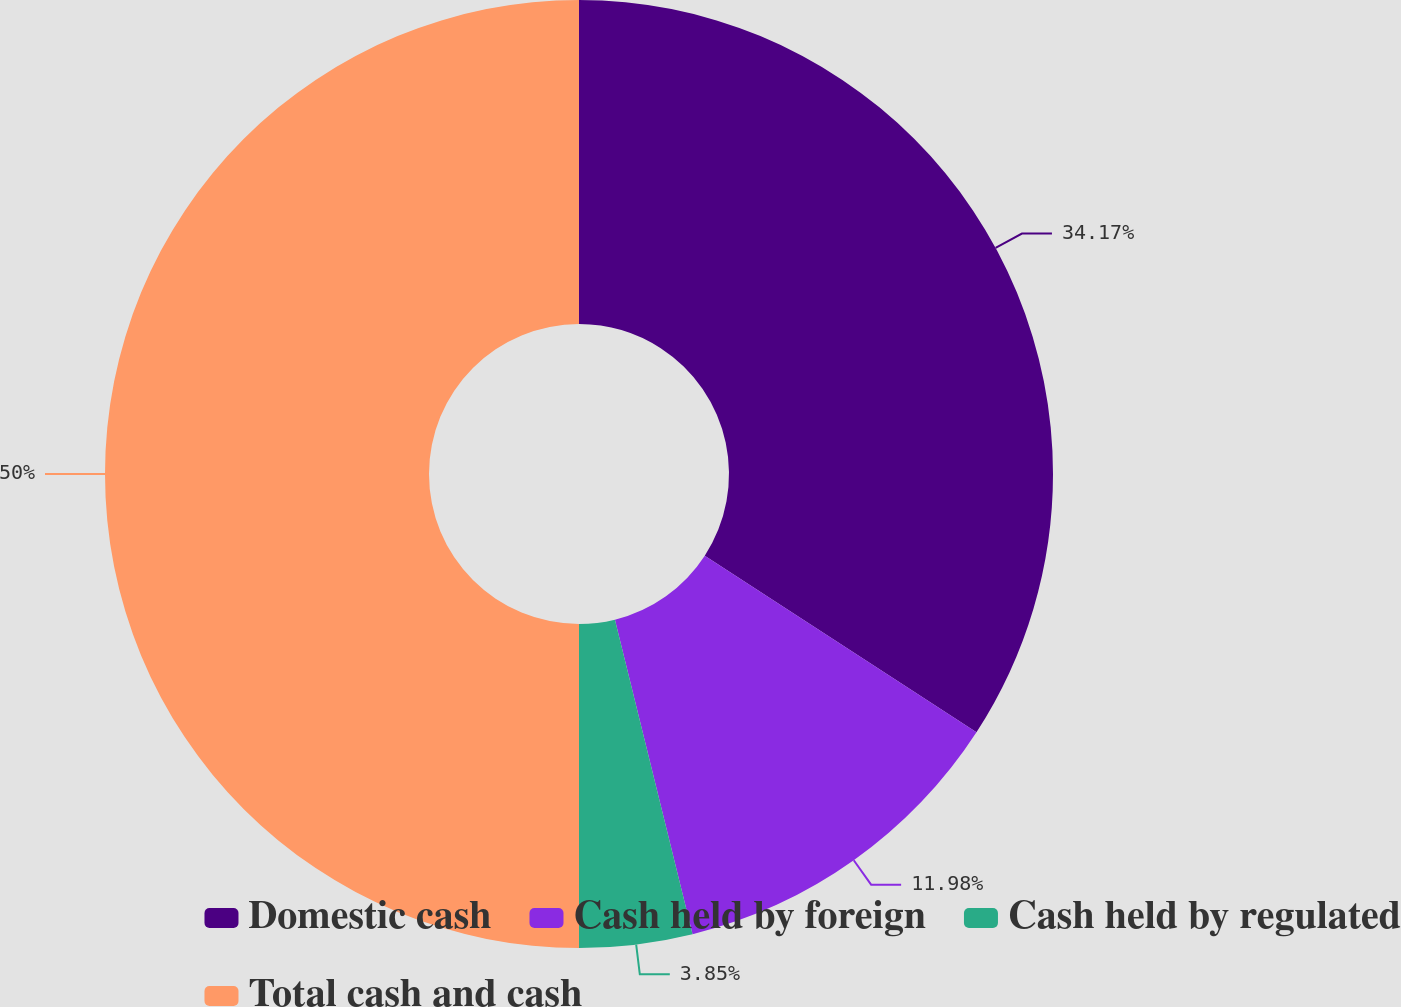Convert chart to OTSL. <chart><loc_0><loc_0><loc_500><loc_500><pie_chart><fcel>Domestic cash<fcel>Cash held by foreign<fcel>Cash held by regulated<fcel>Total cash and cash<nl><fcel>34.17%<fcel>11.98%<fcel>3.85%<fcel>50.0%<nl></chart> 